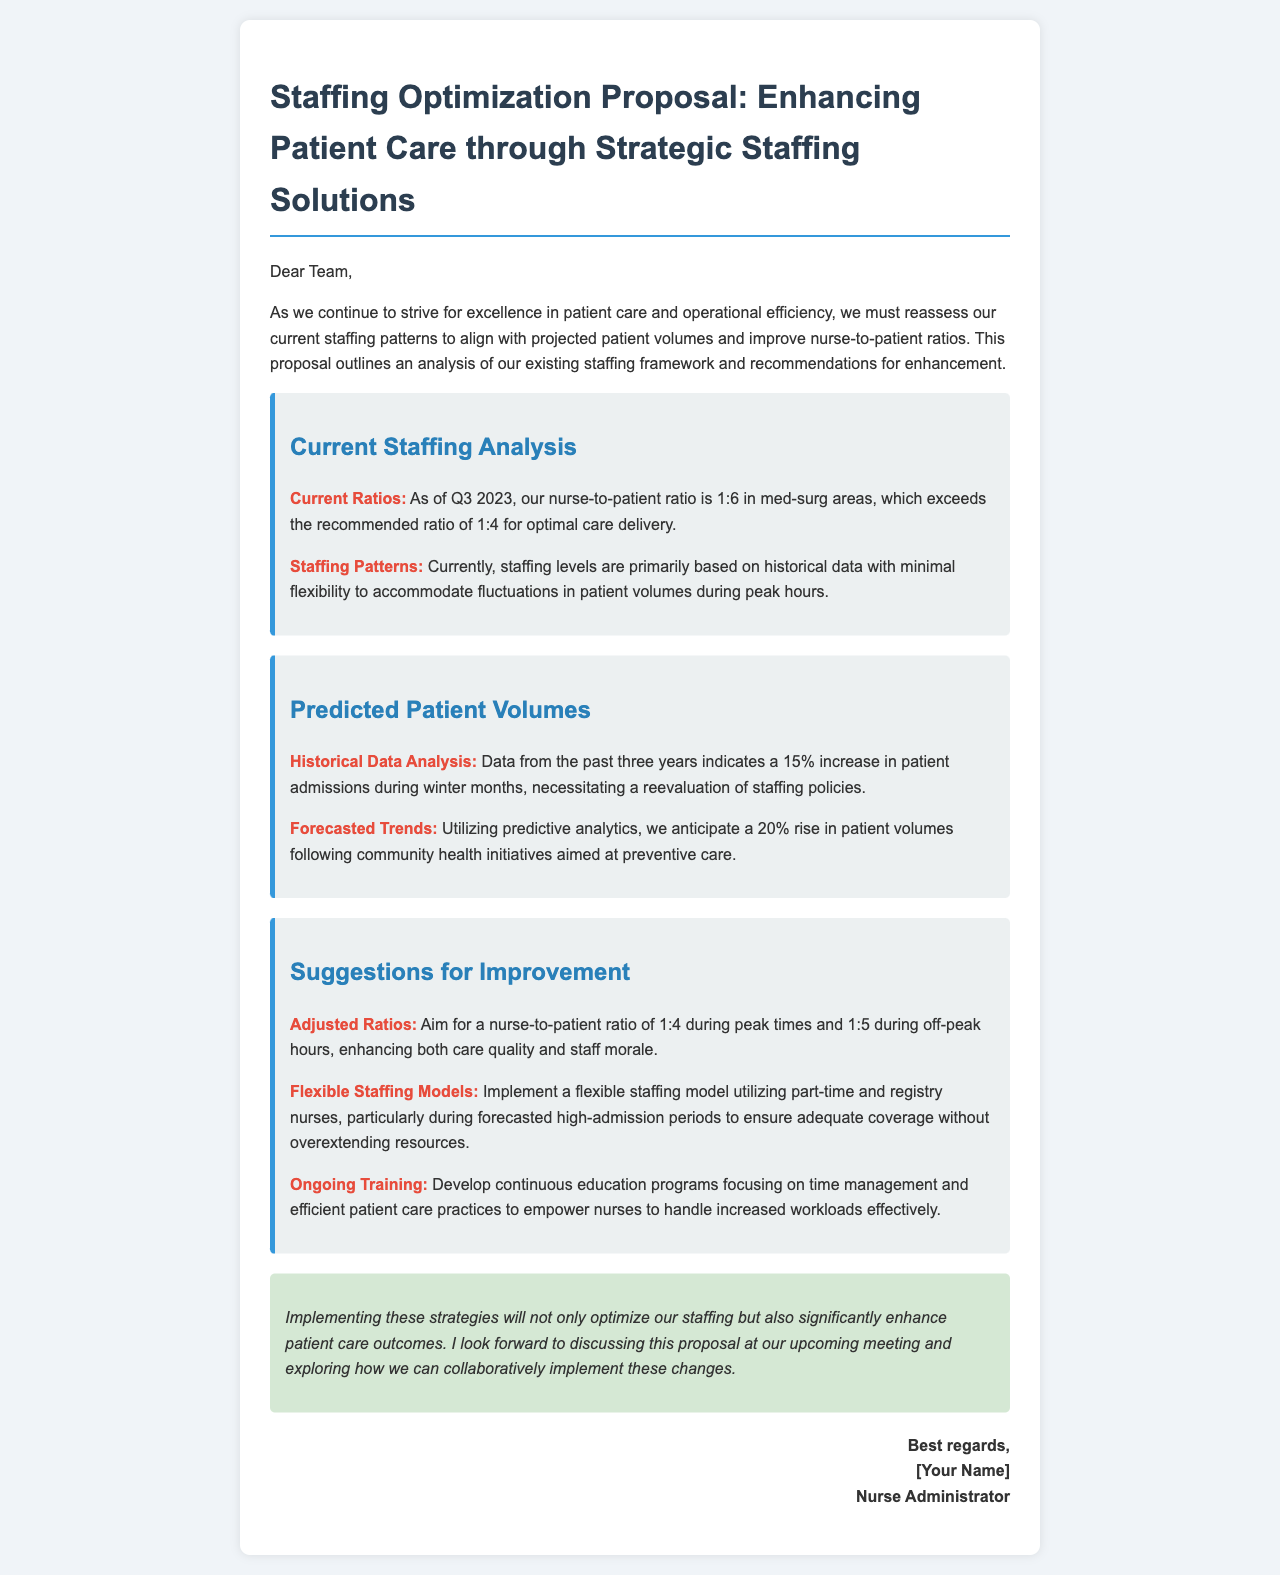What is the nurse-to-patient ratio in med-surg areas? The document states that as of Q3 2023, the nurse-to-patient ratio is 1:6 in med-surg areas.
Answer: 1:6 What is the recommended nurse-to-patient ratio for optimal care delivery? The proposal mentions that the recommended ratio for optimal care delivery is 1:4.
Answer: 1:4 What percentage increase in patient admissions is expected during the winter months? Historical data indicates a 15% increase in patient admissions during winter months.
Answer: 15% What is the forecasted rise in patient volumes following community health initiatives? The document predicts a 20% rise in patient volumes.
Answer: 20% What is one suggestion for improving nurse staffing ratios during off-peak hours? The document suggests aiming for a nurse-to-patient ratio of 1:5 during off-peak hours.
Answer: 1:5 What model is recommended for staffing during high-admission periods? The proposal recommends implementing a flexible staffing model utilizing part-time and registry nurses.
Answer: Flexible staffing model What type of training programs are suggested for nurses? Continuous education programs focusing on time management and efficient patient care practices are suggested.
Answer: Continuous education programs What is the primary goal of implementing these staffing strategies? The primary goal is to optimize staffing and significantly enhance patient care outcomes.
Answer: Enhance patient care outcomes What is the tone of the conclusion in the proposal? The conclusion's tone is optimistic and forward-looking regarding the implementation of the strategies.
Answer: Optimistic 